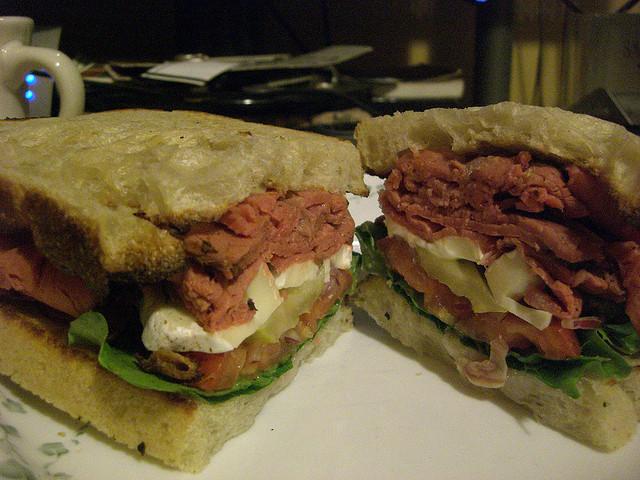What is the sandwich made of?
Short answer required. Roast beef. What is the red vegetable on the sandwich?
Concise answer only. Tomato. What type of meat is in this sandwich?
Keep it brief. Roast beef. Is there bacon on the sandwich?
Concise answer only. No. What is the green vegetable on the sandwich?
Quick response, please. Lettuce. Is the cheese melted?
Keep it brief. No. Is this wrapped in a tortilla?
Be succinct. No. Is someone grabbing the sandwich right now?
Quick response, please. No. Is the sandwich half eaten?
Concise answer only. No. 